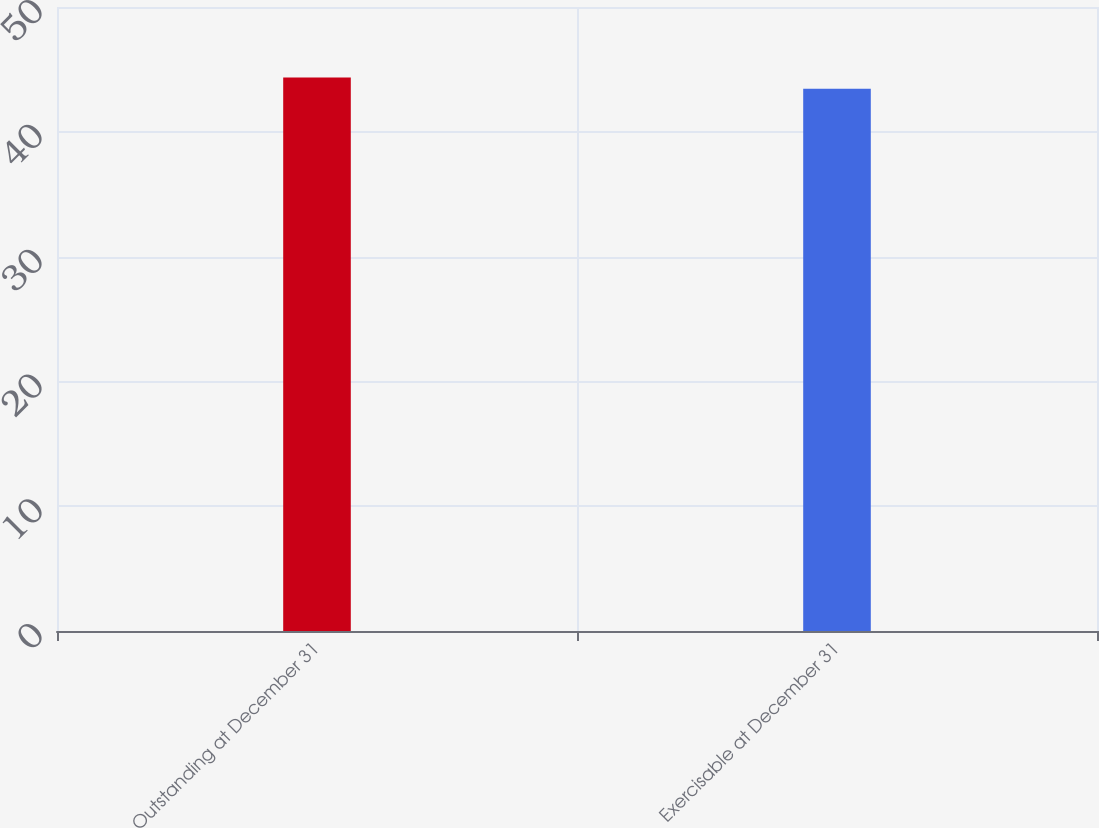Convert chart to OTSL. <chart><loc_0><loc_0><loc_500><loc_500><bar_chart><fcel>Outstanding at December 31<fcel>Exercisable at December 31<nl><fcel>44.36<fcel>43.44<nl></chart> 